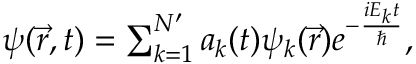Convert formula to latex. <formula><loc_0><loc_0><loc_500><loc_500>\begin{array} { r } { \psi ( \vec { r } , t ) = \sum _ { k = 1 } ^ { N ^ { \prime } } a _ { k } ( t ) \psi _ { k } ( \vec { r } ) e ^ { - \frac { i E _ { k } t } { } } , } \end{array}</formula> 